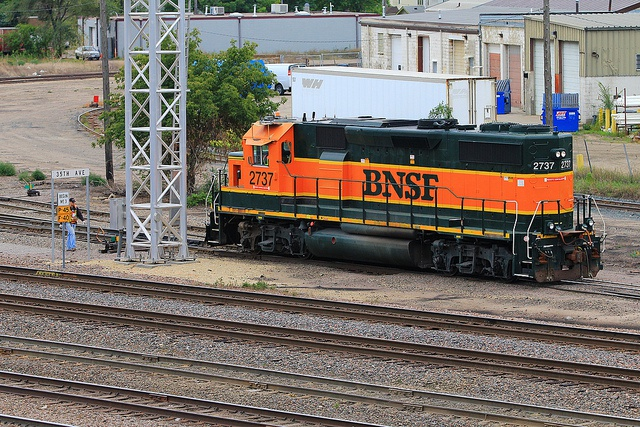Describe the objects in this image and their specific colors. I can see train in black, red, gray, and orange tones, truck in black, lavender, darkgray, gray, and lightgray tones, truck in black, lavender, lightblue, and darkgray tones, car in black, lavender, lightblue, and darkgray tones, and people in black, darkgray, and gray tones in this image. 